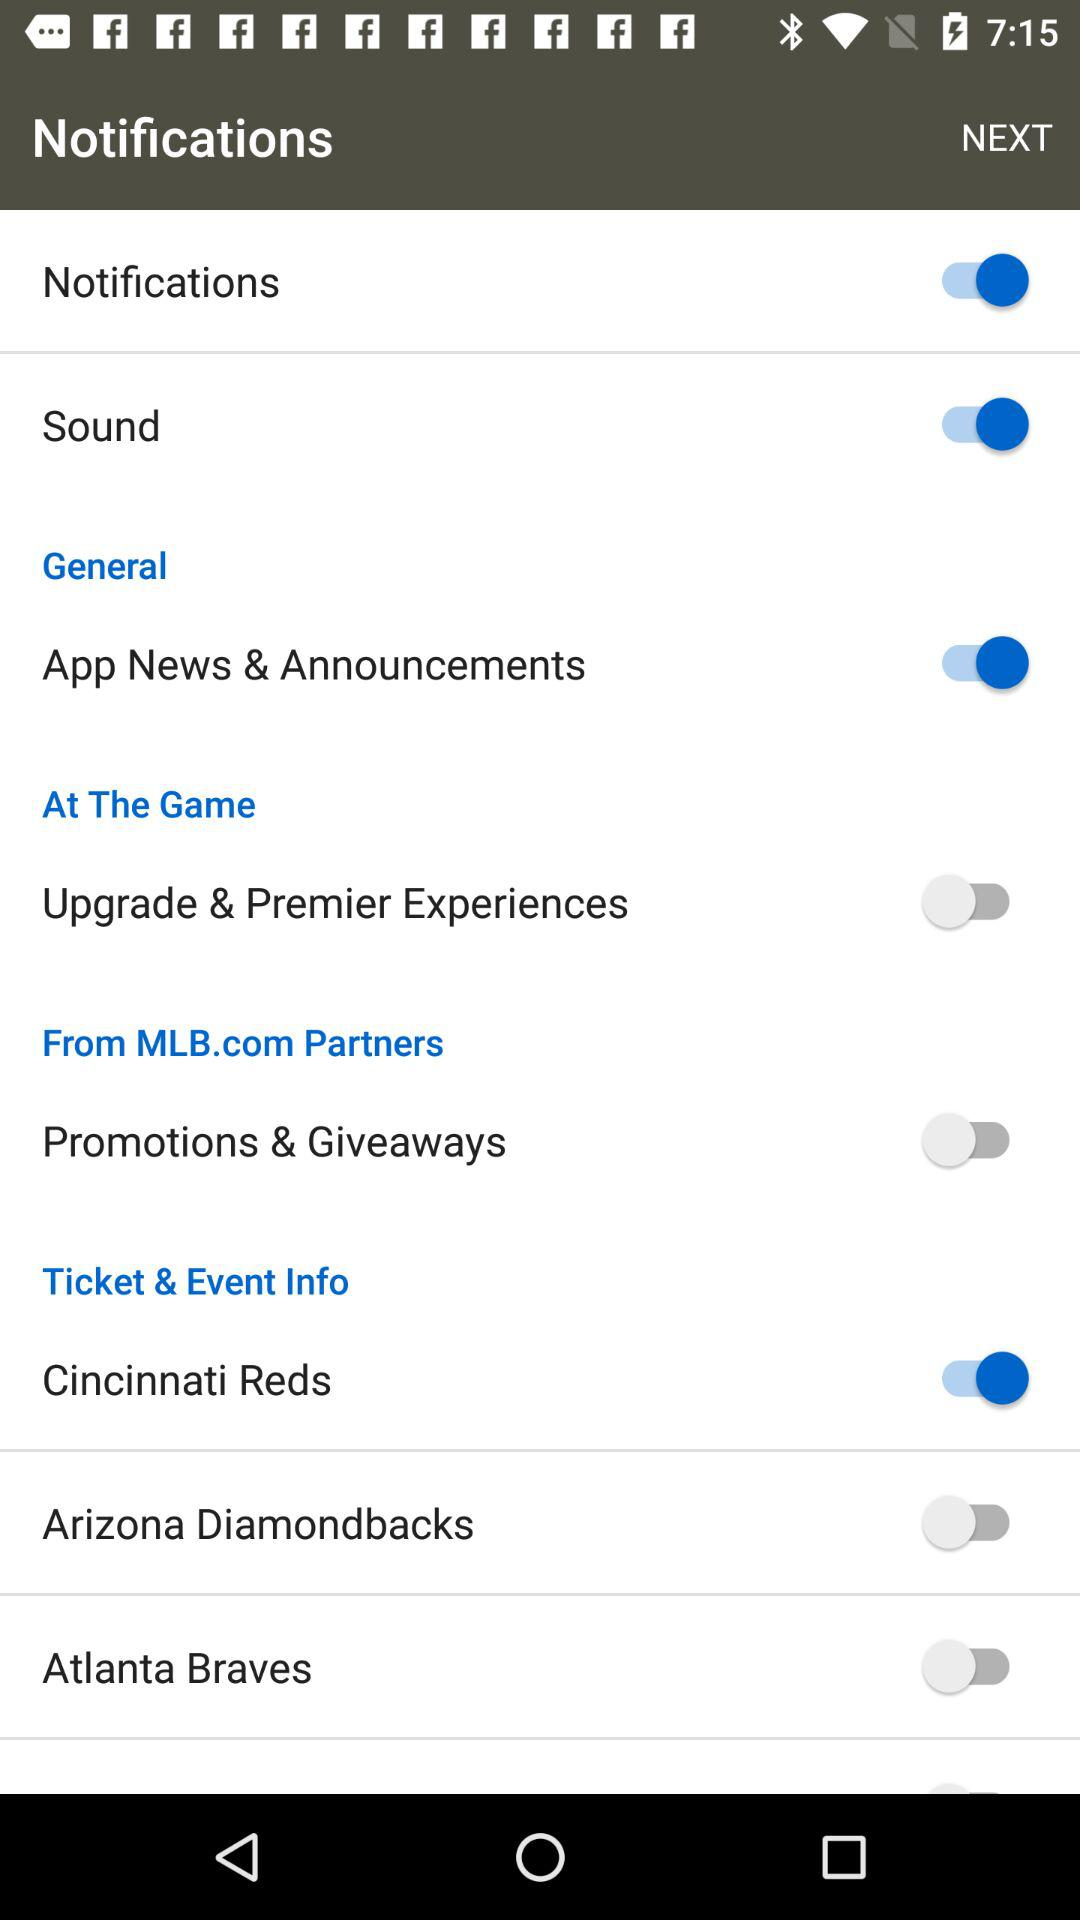What options are enabled? The enabled options are "Notifications", "Sound", "App News & Announcements" and "Cincinnati Reds". 